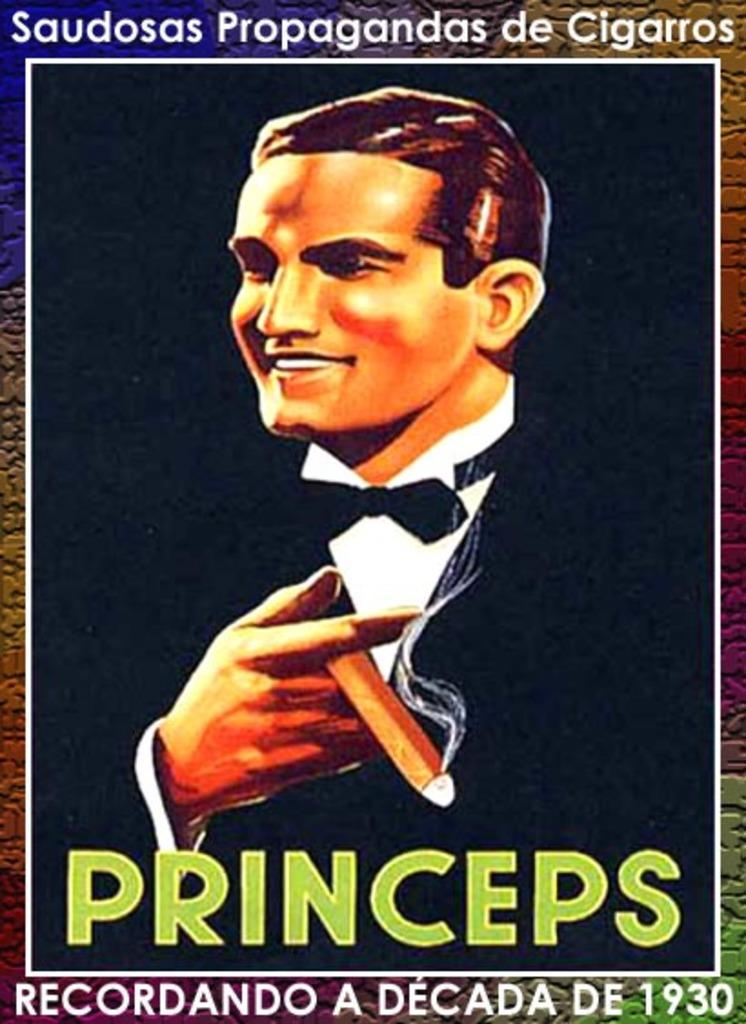What is depicted on the poster in the image? The poster features a man. What else can be seen on the poster besides the man? There is text on the poster. Can you describe the earthquake happening in the background of the poster? There is no earthquake depicted in the image; the poster features a man and text. What type of fiction is the man in the poster reading? There is no indication of the man reading any fiction in the image; the poster only features a man and text. 